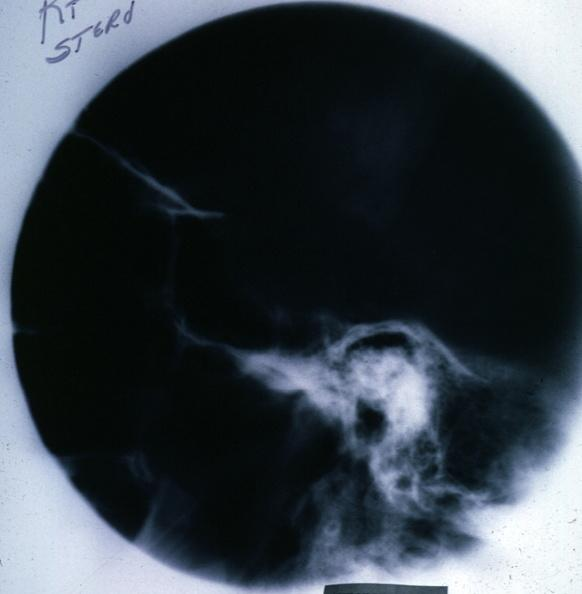what is present?
Answer the question using a single word or phrase. Pituitary 